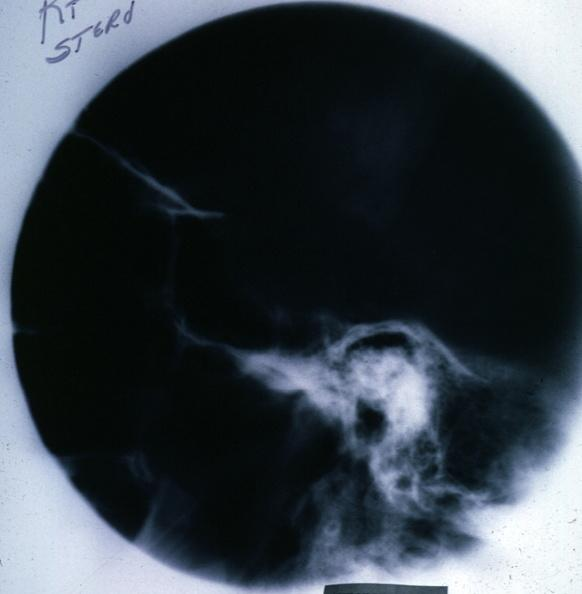what is present?
Answer the question using a single word or phrase. Pituitary 